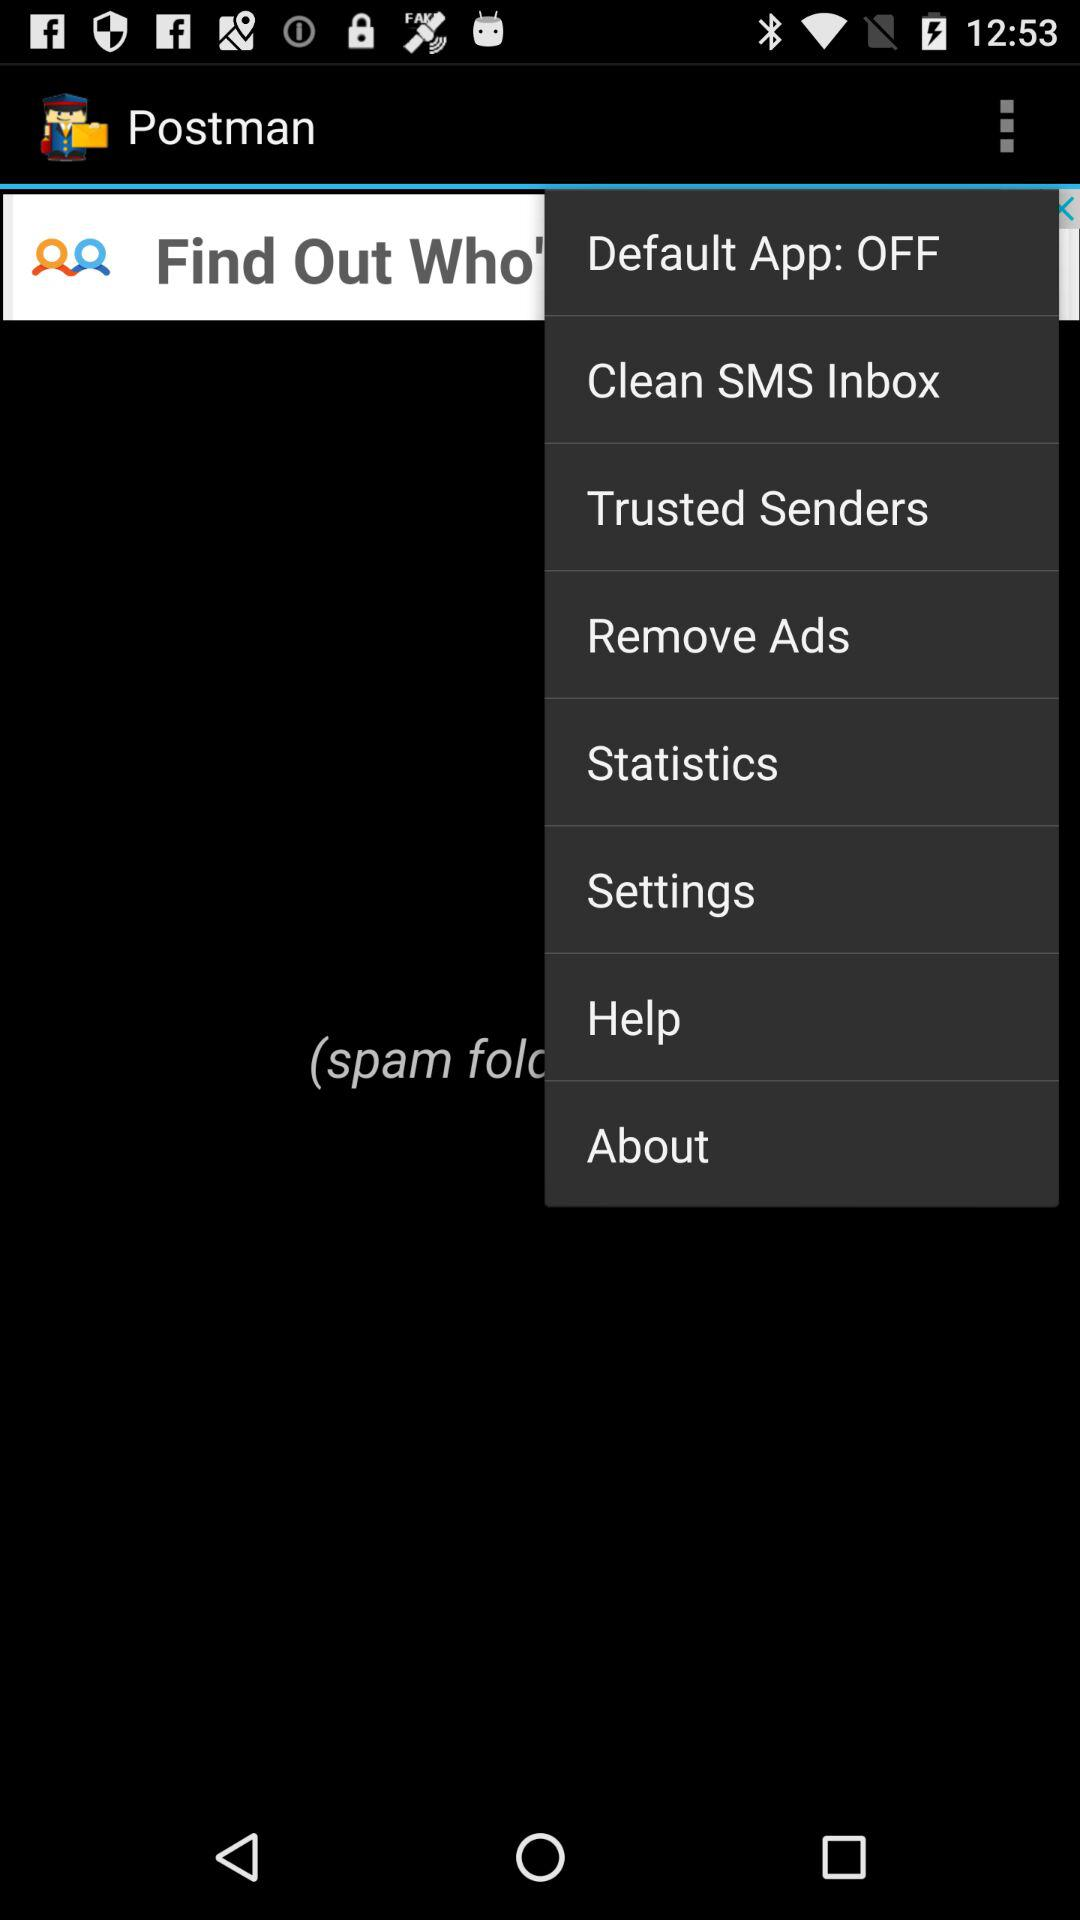What is the app name? The app name is "Postman". 